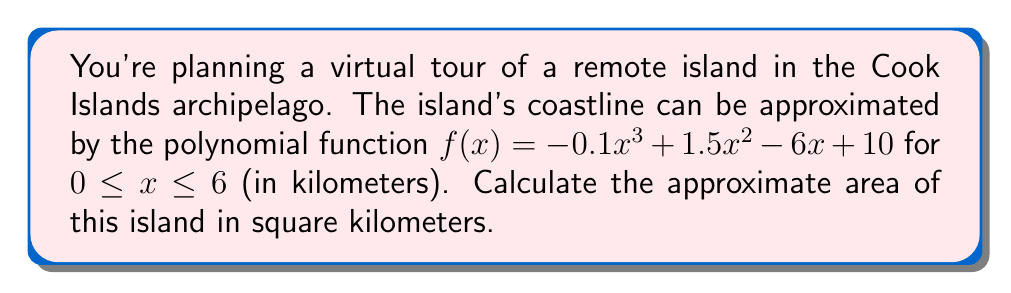Show me your answer to this math problem. To find the area of the island, we need to calculate the definite integral of the polynomial function over the given interval:

1) The area is given by the integral:
   $$A = \int_0^6 f(x) dx = \int_0^6 (-0.1x^3 + 1.5x^2 - 6x + 10) dx$$

2) Integrate each term:
   $$A = [-0.025x^4 + 0.5x^3 - 3x^2 + 10x]_0^6$$

3) Evaluate at the upper and lower bounds:
   Upper bound (x = 6):
   $$-0.025(6^4) + 0.5(6^3) - 3(6^2) + 10(6) = -324 + 648 - 108 + 60 = 276$$
   
   Lower bound (x = 0):
   $$-0.025(0^4) + 0.5(0^3) - 3(0^2) + 10(0) = 0$$

4) Subtract lower bound from upper bound:
   $$A = 276 - 0 = 276$$

Therefore, the approximate area of the island is 276 square kilometers.
Answer: 276 km² 